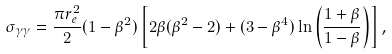<formula> <loc_0><loc_0><loc_500><loc_500>\sigma _ { \gamma \gamma } = \frac { \pi r ^ { 2 } _ { e } } { 2 } ( 1 - \beta ^ { 2 } ) \left [ 2 \beta ( \beta ^ { 2 } - 2 ) + ( 3 - \beta ^ { 4 } ) \ln \left ( \frac { 1 + \beta } { 1 - \beta } \right ) \right ] ,</formula> 